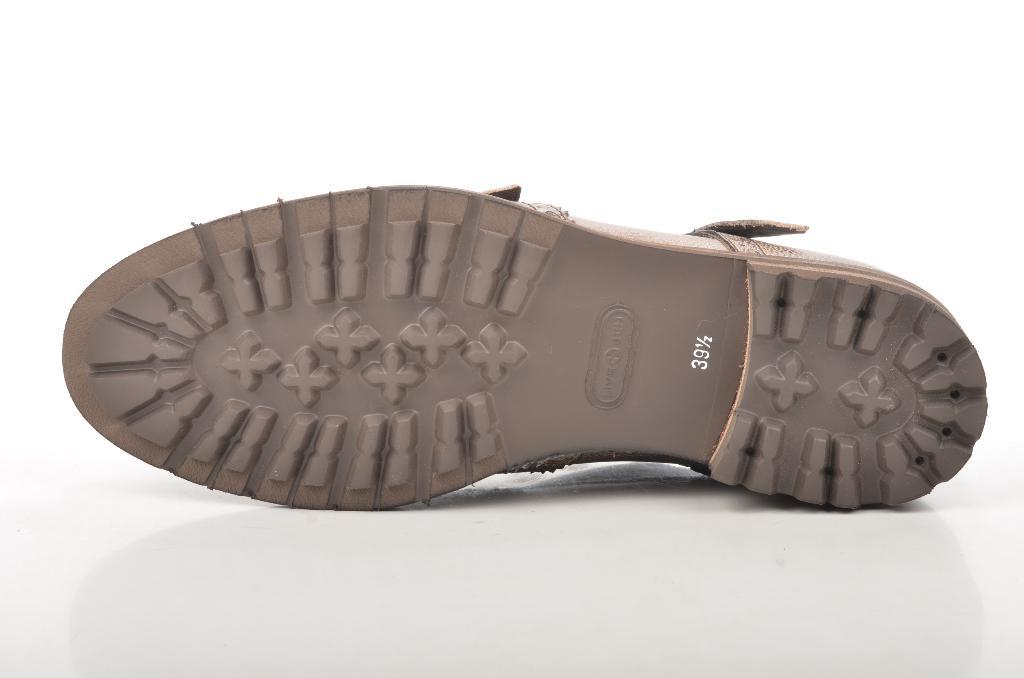What type of object is present in the image? There is footwear in the image. On what surface is the footwear placed? The footwear is on a white color surface. What is the color of the background in the image? The background of the image is white in color. Can you see a cat using a plough in the image? No, there is no cat or plough present in the image. 